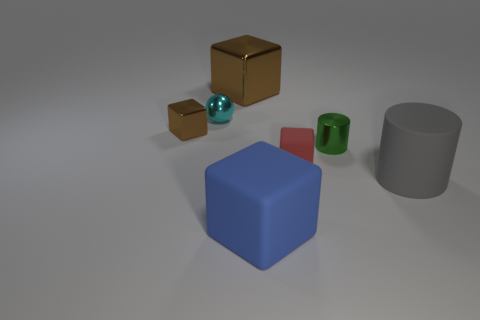There is a metallic cube on the left side of the cyan object; is its size the same as the large brown thing?
Provide a succinct answer. No. What color is the block that is in front of the tiny red object?
Give a very brief answer. Blue. The other metallic object that is the same shape as the big brown object is what color?
Offer a very short reply. Brown. There is a rubber thing to the right of the small metallic thing that is to the right of the small red rubber block; how many small shiny spheres are behind it?
Make the answer very short. 1. Are there fewer tiny red matte cubes behind the red matte object than tiny brown matte things?
Make the answer very short. No. Does the tiny shiny cube have the same color as the big cylinder?
Your response must be concise. No. What size is the other matte object that is the same shape as the red object?
Your answer should be compact. Large. How many green cylinders are the same material as the blue block?
Make the answer very short. 0. Does the cube behind the small sphere have the same material as the small cylinder?
Keep it short and to the point. Yes. Are there the same number of things that are behind the tiny shiny ball and tiny green things?
Provide a succinct answer. Yes. 